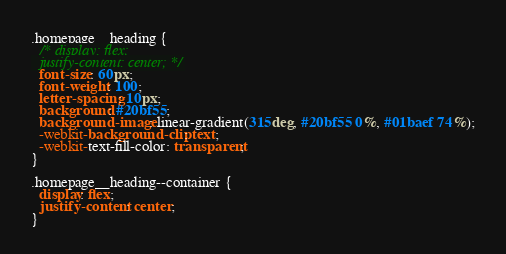<code> <loc_0><loc_0><loc_500><loc_500><_CSS_>.homepage__heading {
  /* display: flex;
  justify-content: center; */
  font-size: 60px;
  font-weight: 100;
  letter-spacing: 10px;
  background: #20bf55;
  background-image: linear-gradient(315deg, #20bf55 0%, #01baef 74%);
  -webkit-background-clip: text;
  -webkit-text-fill-color: transparent;
}

.homepage__heading--container {
  display: flex;
  justify-content: center;
}
</code> 